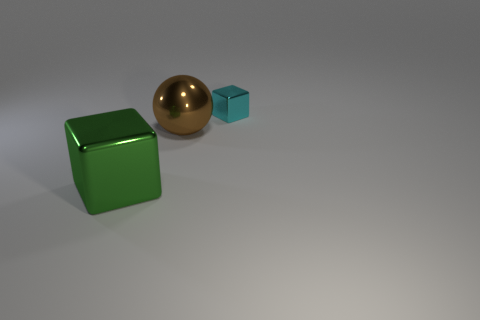Add 2 big brown metal balls. How many objects exist? 5 Subtract 1 blocks. How many blocks are left? 1 Subtract all cyan blocks. How many blocks are left? 1 Subtract 0 red spheres. How many objects are left? 3 Subtract all balls. How many objects are left? 2 Subtract all yellow spheres. Subtract all purple cubes. How many spheres are left? 1 Subtract all red blocks. How many red spheres are left? 0 Subtract all cyan objects. Subtract all large metallic things. How many objects are left? 0 Add 1 cyan cubes. How many cyan cubes are left? 2 Add 3 metal balls. How many metal balls exist? 4 